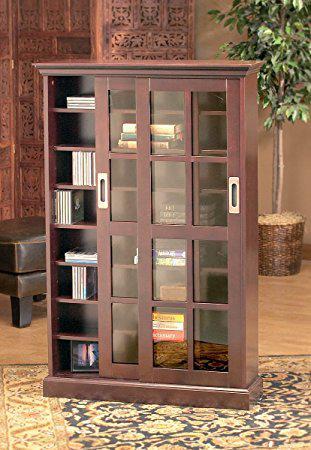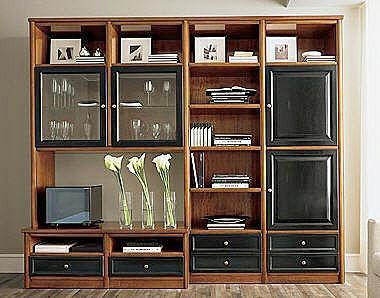The first image is the image on the left, the second image is the image on the right. Evaluate the accuracy of this statement regarding the images: "A bookcase in one image has upper glass doors with panes, over a solid lower section.". Is it true? Answer yes or no. No. 